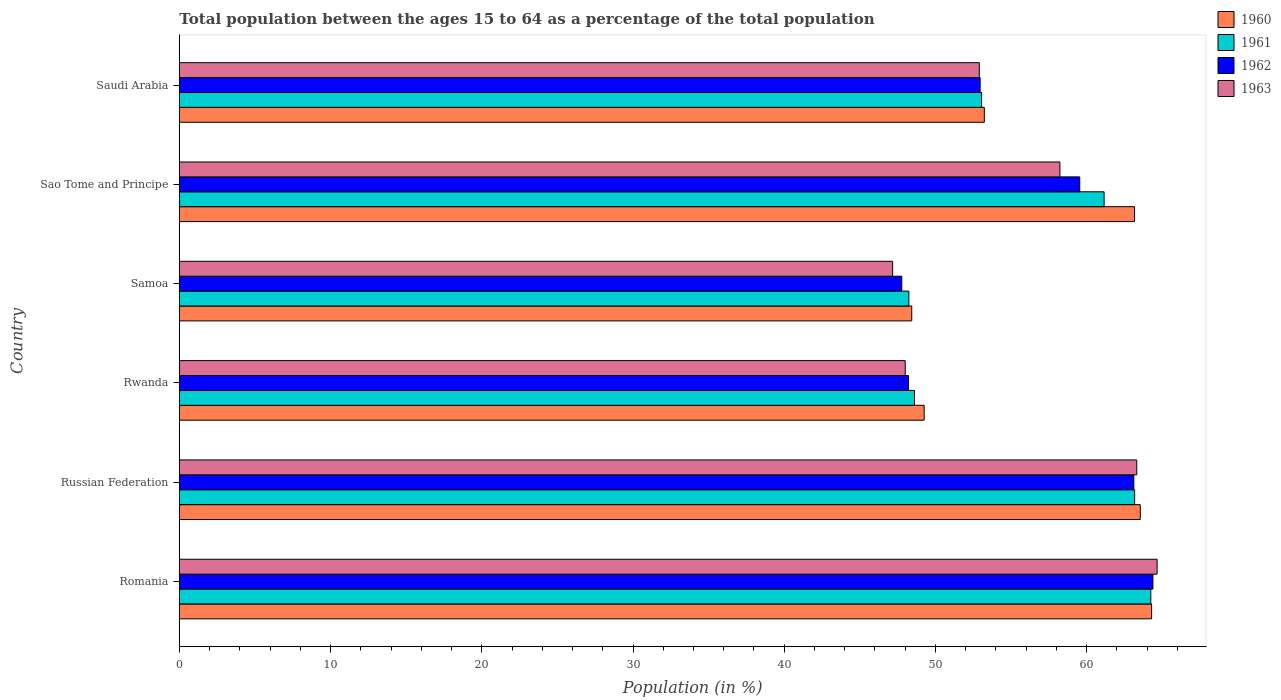How many different coloured bars are there?
Provide a short and direct response. 4. How many groups of bars are there?
Your answer should be very brief. 6. Are the number of bars on each tick of the Y-axis equal?
Provide a short and direct response. Yes. What is the label of the 6th group of bars from the top?
Your answer should be very brief. Romania. In how many cases, is the number of bars for a given country not equal to the number of legend labels?
Ensure brevity in your answer.  0. What is the percentage of the population ages 15 to 64 in 1963 in Sao Tome and Principe?
Your response must be concise. 58.23. Across all countries, what is the maximum percentage of the population ages 15 to 64 in 1963?
Provide a short and direct response. 64.66. Across all countries, what is the minimum percentage of the population ages 15 to 64 in 1960?
Your answer should be very brief. 48.43. In which country was the percentage of the population ages 15 to 64 in 1961 maximum?
Give a very brief answer. Romania. In which country was the percentage of the population ages 15 to 64 in 1962 minimum?
Offer a very short reply. Samoa. What is the total percentage of the population ages 15 to 64 in 1963 in the graph?
Your answer should be compact. 334.28. What is the difference between the percentage of the population ages 15 to 64 in 1962 in Russian Federation and that in Rwanda?
Make the answer very short. 14.9. What is the difference between the percentage of the population ages 15 to 64 in 1960 in Russian Federation and the percentage of the population ages 15 to 64 in 1961 in Romania?
Your response must be concise. -0.7. What is the average percentage of the population ages 15 to 64 in 1960 per country?
Keep it short and to the point. 56.99. What is the difference between the percentage of the population ages 15 to 64 in 1962 and percentage of the population ages 15 to 64 in 1963 in Romania?
Your answer should be compact. -0.28. In how many countries, is the percentage of the population ages 15 to 64 in 1960 greater than 46 ?
Make the answer very short. 6. What is the ratio of the percentage of the population ages 15 to 64 in 1960 in Russian Federation to that in Sao Tome and Principe?
Make the answer very short. 1.01. Is the percentage of the population ages 15 to 64 in 1961 in Samoa less than that in Sao Tome and Principe?
Ensure brevity in your answer.  Yes. What is the difference between the highest and the second highest percentage of the population ages 15 to 64 in 1961?
Your response must be concise. 1.07. What is the difference between the highest and the lowest percentage of the population ages 15 to 64 in 1963?
Offer a terse response. 17.49. In how many countries, is the percentage of the population ages 15 to 64 in 1963 greater than the average percentage of the population ages 15 to 64 in 1963 taken over all countries?
Keep it short and to the point. 3. Is the sum of the percentage of the population ages 15 to 64 in 1961 in Romania and Samoa greater than the maximum percentage of the population ages 15 to 64 in 1960 across all countries?
Provide a succinct answer. Yes. Is it the case that in every country, the sum of the percentage of the population ages 15 to 64 in 1963 and percentage of the population ages 15 to 64 in 1962 is greater than the sum of percentage of the population ages 15 to 64 in 1960 and percentage of the population ages 15 to 64 in 1961?
Give a very brief answer. No. How many bars are there?
Your response must be concise. 24. Are all the bars in the graph horizontal?
Give a very brief answer. Yes. What is the title of the graph?
Your answer should be very brief. Total population between the ages 15 to 64 as a percentage of the total population. What is the label or title of the X-axis?
Make the answer very short. Population (in %). What is the Population (in %) of 1960 in Romania?
Make the answer very short. 64.3. What is the Population (in %) of 1961 in Romania?
Your answer should be very brief. 64.24. What is the Population (in %) of 1962 in Romania?
Your answer should be very brief. 64.38. What is the Population (in %) of 1963 in Romania?
Offer a very short reply. 64.66. What is the Population (in %) of 1960 in Russian Federation?
Give a very brief answer. 63.55. What is the Population (in %) of 1961 in Russian Federation?
Offer a very short reply. 63.18. What is the Population (in %) of 1962 in Russian Federation?
Your answer should be compact. 63.12. What is the Population (in %) in 1963 in Russian Federation?
Your answer should be compact. 63.31. What is the Population (in %) of 1960 in Rwanda?
Provide a short and direct response. 49.26. What is the Population (in %) in 1961 in Rwanda?
Give a very brief answer. 48.62. What is the Population (in %) of 1962 in Rwanda?
Provide a short and direct response. 48.22. What is the Population (in %) of 1963 in Rwanda?
Provide a succinct answer. 48. What is the Population (in %) of 1960 in Samoa?
Offer a very short reply. 48.43. What is the Population (in %) in 1961 in Samoa?
Offer a terse response. 48.24. What is the Population (in %) in 1962 in Samoa?
Your response must be concise. 47.77. What is the Population (in %) in 1963 in Samoa?
Provide a short and direct response. 47.17. What is the Population (in %) in 1960 in Sao Tome and Principe?
Provide a short and direct response. 63.17. What is the Population (in %) in 1961 in Sao Tome and Principe?
Offer a very short reply. 61.16. What is the Population (in %) in 1962 in Sao Tome and Principe?
Offer a very short reply. 59.54. What is the Population (in %) of 1963 in Sao Tome and Principe?
Make the answer very short. 58.23. What is the Population (in %) in 1960 in Saudi Arabia?
Provide a succinct answer. 53.23. What is the Population (in %) of 1961 in Saudi Arabia?
Keep it short and to the point. 53.05. What is the Population (in %) in 1962 in Saudi Arabia?
Keep it short and to the point. 52.96. What is the Population (in %) of 1963 in Saudi Arabia?
Keep it short and to the point. 52.9. Across all countries, what is the maximum Population (in %) in 1960?
Your answer should be compact. 64.3. Across all countries, what is the maximum Population (in %) in 1961?
Offer a terse response. 64.24. Across all countries, what is the maximum Population (in %) in 1962?
Offer a very short reply. 64.38. Across all countries, what is the maximum Population (in %) of 1963?
Provide a succinct answer. 64.66. Across all countries, what is the minimum Population (in %) in 1960?
Make the answer very short. 48.43. Across all countries, what is the minimum Population (in %) in 1961?
Your response must be concise. 48.24. Across all countries, what is the minimum Population (in %) of 1962?
Offer a very short reply. 47.77. Across all countries, what is the minimum Population (in %) of 1963?
Offer a terse response. 47.17. What is the total Population (in %) of 1960 in the graph?
Make the answer very short. 341.94. What is the total Population (in %) of 1961 in the graph?
Make the answer very short. 338.49. What is the total Population (in %) of 1962 in the graph?
Provide a short and direct response. 336. What is the total Population (in %) in 1963 in the graph?
Offer a terse response. 334.28. What is the difference between the Population (in %) of 1960 in Romania and that in Russian Federation?
Your answer should be very brief. 0.75. What is the difference between the Population (in %) in 1961 in Romania and that in Russian Federation?
Offer a very short reply. 1.07. What is the difference between the Population (in %) of 1962 in Romania and that in Russian Federation?
Offer a terse response. 1.26. What is the difference between the Population (in %) in 1963 in Romania and that in Russian Federation?
Ensure brevity in your answer.  1.35. What is the difference between the Population (in %) of 1960 in Romania and that in Rwanda?
Offer a very short reply. 15.04. What is the difference between the Population (in %) in 1961 in Romania and that in Rwanda?
Make the answer very short. 15.63. What is the difference between the Population (in %) of 1962 in Romania and that in Rwanda?
Make the answer very short. 16.17. What is the difference between the Population (in %) of 1963 in Romania and that in Rwanda?
Give a very brief answer. 16.66. What is the difference between the Population (in %) of 1960 in Romania and that in Samoa?
Give a very brief answer. 15.86. What is the difference between the Population (in %) of 1961 in Romania and that in Samoa?
Your response must be concise. 16. What is the difference between the Population (in %) of 1962 in Romania and that in Samoa?
Your answer should be very brief. 16.61. What is the difference between the Population (in %) of 1963 in Romania and that in Samoa?
Your answer should be compact. 17.49. What is the difference between the Population (in %) of 1960 in Romania and that in Sao Tome and Principe?
Make the answer very short. 1.13. What is the difference between the Population (in %) in 1961 in Romania and that in Sao Tome and Principe?
Give a very brief answer. 3.09. What is the difference between the Population (in %) of 1962 in Romania and that in Sao Tome and Principe?
Give a very brief answer. 4.84. What is the difference between the Population (in %) of 1963 in Romania and that in Sao Tome and Principe?
Your answer should be very brief. 6.43. What is the difference between the Population (in %) in 1960 in Romania and that in Saudi Arabia?
Offer a terse response. 11.06. What is the difference between the Population (in %) of 1961 in Romania and that in Saudi Arabia?
Your answer should be very brief. 11.19. What is the difference between the Population (in %) in 1962 in Romania and that in Saudi Arabia?
Provide a succinct answer. 11.43. What is the difference between the Population (in %) in 1963 in Romania and that in Saudi Arabia?
Your answer should be compact. 11.76. What is the difference between the Population (in %) in 1960 in Russian Federation and that in Rwanda?
Give a very brief answer. 14.29. What is the difference between the Population (in %) in 1961 in Russian Federation and that in Rwanda?
Your response must be concise. 14.56. What is the difference between the Population (in %) in 1962 in Russian Federation and that in Rwanda?
Offer a very short reply. 14.9. What is the difference between the Population (in %) in 1963 in Russian Federation and that in Rwanda?
Keep it short and to the point. 15.31. What is the difference between the Population (in %) of 1960 in Russian Federation and that in Samoa?
Your answer should be compact. 15.11. What is the difference between the Population (in %) in 1961 in Russian Federation and that in Samoa?
Your response must be concise. 14.93. What is the difference between the Population (in %) in 1962 in Russian Federation and that in Samoa?
Offer a terse response. 15.35. What is the difference between the Population (in %) in 1963 in Russian Federation and that in Samoa?
Make the answer very short. 16.15. What is the difference between the Population (in %) in 1960 in Russian Federation and that in Sao Tome and Principe?
Your answer should be compact. 0.38. What is the difference between the Population (in %) of 1961 in Russian Federation and that in Sao Tome and Principe?
Give a very brief answer. 2.02. What is the difference between the Population (in %) in 1962 in Russian Federation and that in Sao Tome and Principe?
Your answer should be compact. 3.58. What is the difference between the Population (in %) of 1963 in Russian Federation and that in Sao Tome and Principe?
Give a very brief answer. 5.08. What is the difference between the Population (in %) in 1960 in Russian Federation and that in Saudi Arabia?
Provide a succinct answer. 10.31. What is the difference between the Population (in %) of 1961 in Russian Federation and that in Saudi Arabia?
Offer a very short reply. 10.12. What is the difference between the Population (in %) of 1962 in Russian Federation and that in Saudi Arabia?
Your response must be concise. 10.16. What is the difference between the Population (in %) of 1963 in Russian Federation and that in Saudi Arabia?
Ensure brevity in your answer.  10.41. What is the difference between the Population (in %) in 1960 in Rwanda and that in Samoa?
Your response must be concise. 0.82. What is the difference between the Population (in %) of 1961 in Rwanda and that in Samoa?
Ensure brevity in your answer.  0.37. What is the difference between the Population (in %) in 1962 in Rwanda and that in Samoa?
Provide a short and direct response. 0.44. What is the difference between the Population (in %) of 1963 in Rwanda and that in Samoa?
Offer a terse response. 0.83. What is the difference between the Population (in %) in 1960 in Rwanda and that in Sao Tome and Principe?
Your answer should be compact. -13.91. What is the difference between the Population (in %) of 1961 in Rwanda and that in Sao Tome and Principe?
Offer a terse response. -12.54. What is the difference between the Population (in %) in 1962 in Rwanda and that in Sao Tome and Principe?
Provide a short and direct response. -11.33. What is the difference between the Population (in %) in 1963 in Rwanda and that in Sao Tome and Principe?
Keep it short and to the point. -10.23. What is the difference between the Population (in %) of 1960 in Rwanda and that in Saudi Arabia?
Ensure brevity in your answer.  -3.98. What is the difference between the Population (in %) in 1961 in Rwanda and that in Saudi Arabia?
Offer a terse response. -4.44. What is the difference between the Population (in %) in 1962 in Rwanda and that in Saudi Arabia?
Your response must be concise. -4.74. What is the difference between the Population (in %) in 1963 in Rwanda and that in Saudi Arabia?
Offer a very short reply. -4.9. What is the difference between the Population (in %) in 1960 in Samoa and that in Sao Tome and Principe?
Your answer should be compact. -14.73. What is the difference between the Population (in %) in 1961 in Samoa and that in Sao Tome and Principe?
Offer a terse response. -12.91. What is the difference between the Population (in %) of 1962 in Samoa and that in Sao Tome and Principe?
Keep it short and to the point. -11.77. What is the difference between the Population (in %) of 1963 in Samoa and that in Sao Tome and Principe?
Provide a succinct answer. -11.06. What is the difference between the Population (in %) in 1960 in Samoa and that in Saudi Arabia?
Your response must be concise. -4.8. What is the difference between the Population (in %) of 1961 in Samoa and that in Saudi Arabia?
Your response must be concise. -4.81. What is the difference between the Population (in %) of 1962 in Samoa and that in Saudi Arabia?
Offer a very short reply. -5.18. What is the difference between the Population (in %) in 1963 in Samoa and that in Saudi Arabia?
Keep it short and to the point. -5.73. What is the difference between the Population (in %) in 1960 in Sao Tome and Principe and that in Saudi Arabia?
Keep it short and to the point. 9.94. What is the difference between the Population (in %) in 1961 in Sao Tome and Principe and that in Saudi Arabia?
Provide a short and direct response. 8.1. What is the difference between the Population (in %) in 1962 in Sao Tome and Principe and that in Saudi Arabia?
Your answer should be compact. 6.59. What is the difference between the Population (in %) of 1963 in Sao Tome and Principe and that in Saudi Arabia?
Give a very brief answer. 5.33. What is the difference between the Population (in %) in 1960 in Romania and the Population (in %) in 1961 in Russian Federation?
Provide a short and direct response. 1.12. What is the difference between the Population (in %) of 1960 in Romania and the Population (in %) of 1962 in Russian Federation?
Your answer should be very brief. 1.18. What is the difference between the Population (in %) in 1960 in Romania and the Population (in %) in 1963 in Russian Federation?
Provide a short and direct response. 0.98. What is the difference between the Population (in %) in 1961 in Romania and the Population (in %) in 1962 in Russian Federation?
Ensure brevity in your answer.  1.12. What is the difference between the Population (in %) in 1961 in Romania and the Population (in %) in 1963 in Russian Federation?
Keep it short and to the point. 0.93. What is the difference between the Population (in %) of 1962 in Romania and the Population (in %) of 1963 in Russian Federation?
Provide a short and direct response. 1.07. What is the difference between the Population (in %) of 1960 in Romania and the Population (in %) of 1961 in Rwanda?
Make the answer very short. 15.68. What is the difference between the Population (in %) of 1960 in Romania and the Population (in %) of 1962 in Rwanda?
Make the answer very short. 16.08. What is the difference between the Population (in %) of 1960 in Romania and the Population (in %) of 1963 in Rwanda?
Provide a short and direct response. 16.29. What is the difference between the Population (in %) of 1961 in Romania and the Population (in %) of 1962 in Rwanda?
Keep it short and to the point. 16.03. What is the difference between the Population (in %) in 1961 in Romania and the Population (in %) in 1963 in Rwanda?
Give a very brief answer. 16.24. What is the difference between the Population (in %) of 1962 in Romania and the Population (in %) of 1963 in Rwanda?
Your answer should be compact. 16.38. What is the difference between the Population (in %) of 1960 in Romania and the Population (in %) of 1961 in Samoa?
Provide a short and direct response. 16.05. What is the difference between the Population (in %) in 1960 in Romania and the Population (in %) in 1962 in Samoa?
Provide a short and direct response. 16.52. What is the difference between the Population (in %) in 1960 in Romania and the Population (in %) in 1963 in Samoa?
Your response must be concise. 17.13. What is the difference between the Population (in %) in 1961 in Romania and the Population (in %) in 1962 in Samoa?
Your response must be concise. 16.47. What is the difference between the Population (in %) of 1961 in Romania and the Population (in %) of 1963 in Samoa?
Your response must be concise. 17.07. What is the difference between the Population (in %) in 1962 in Romania and the Population (in %) in 1963 in Samoa?
Keep it short and to the point. 17.21. What is the difference between the Population (in %) of 1960 in Romania and the Population (in %) of 1961 in Sao Tome and Principe?
Make the answer very short. 3.14. What is the difference between the Population (in %) in 1960 in Romania and the Population (in %) in 1962 in Sao Tome and Principe?
Your answer should be compact. 4.75. What is the difference between the Population (in %) of 1960 in Romania and the Population (in %) of 1963 in Sao Tome and Principe?
Provide a short and direct response. 6.06. What is the difference between the Population (in %) of 1961 in Romania and the Population (in %) of 1962 in Sao Tome and Principe?
Provide a succinct answer. 4.7. What is the difference between the Population (in %) of 1961 in Romania and the Population (in %) of 1963 in Sao Tome and Principe?
Offer a very short reply. 6.01. What is the difference between the Population (in %) in 1962 in Romania and the Population (in %) in 1963 in Sao Tome and Principe?
Provide a short and direct response. 6.15. What is the difference between the Population (in %) of 1960 in Romania and the Population (in %) of 1961 in Saudi Arabia?
Your answer should be compact. 11.24. What is the difference between the Population (in %) of 1960 in Romania and the Population (in %) of 1962 in Saudi Arabia?
Make the answer very short. 11.34. What is the difference between the Population (in %) in 1960 in Romania and the Population (in %) in 1963 in Saudi Arabia?
Ensure brevity in your answer.  11.4. What is the difference between the Population (in %) of 1961 in Romania and the Population (in %) of 1962 in Saudi Arabia?
Provide a succinct answer. 11.29. What is the difference between the Population (in %) in 1961 in Romania and the Population (in %) in 1963 in Saudi Arabia?
Make the answer very short. 11.34. What is the difference between the Population (in %) in 1962 in Romania and the Population (in %) in 1963 in Saudi Arabia?
Your response must be concise. 11.48. What is the difference between the Population (in %) of 1960 in Russian Federation and the Population (in %) of 1961 in Rwanda?
Give a very brief answer. 14.93. What is the difference between the Population (in %) of 1960 in Russian Federation and the Population (in %) of 1962 in Rwanda?
Keep it short and to the point. 15.33. What is the difference between the Population (in %) of 1960 in Russian Federation and the Population (in %) of 1963 in Rwanda?
Give a very brief answer. 15.55. What is the difference between the Population (in %) in 1961 in Russian Federation and the Population (in %) in 1962 in Rwanda?
Provide a succinct answer. 14.96. What is the difference between the Population (in %) of 1961 in Russian Federation and the Population (in %) of 1963 in Rwanda?
Offer a very short reply. 15.17. What is the difference between the Population (in %) of 1962 in Russian Federation and the Population (in %) of 1963 in Rwanda?
Ensure brevity in your answer.  15.12. What is the difference between the Population (in %) in 1960 in Russian Federation and the Population (in %) in 1961 in Samoa?
Provide a succinct answer. 15.31. What is the difference between the Population (in %) of 1960 in Russian Federation and the Population (in %) of 1962 in Samoa?
Ensure brevity in your answer.  15.78. What is the difference between the Population (in %) of 1960 in Russian Federation and the Population (in %) of 1963 in Samoa?
Keep it short and to the point. 16.38. What is the difference between the Population (in %) in 1961 in Russian Federation and the Population (in %) in 1962 in Samoa?
Make the answer very short. 15.4. What is the difference between the Population (in %) in 1961 in Russian Federation and the Population (in %) in 1963 in Samoa?
Make the answer very short. 16.01. What is the difference between the Population (in %) in 1962 in Russian Federation and the Population (in %) in 1963 in Samoa?
Your response must be concise. 15.95. What is the difference between the Population (in %) in 1960 in Russian Federation and the Population (in %) in 1961 in Sao Tome and Principe?
Give a very brief answer. 2.39. What is the difference between the Population (in %) in 1960 in Russian Federation and the Population (in %) in 1962 in Sao Tome and Principe?
Offer a terse response. 4. What is the difference between the Population (in %) in 1960 in Russian Federation and the Population (in %) in 1963 in Sao Tome and Principe?
Make the answer very short. 5.32. What is the difference between the Population (in %) in 1961 in Russian Federation and the Population (in %) in 1962 in Sao Tome and Principe?
Your answer should be compact. 3.63. What is the difference between the Population (in %) of 1961 in Russian Federation and the Population (in %) of 1963 in Sao Tome and Principe?
Your answer should be very brief. 4.94. What is the difference between the Population (in %) in 1962 in Russian Federation and the Population (in %) in 1963 in Sao Tome and Principe?
Provide a short and direct response. 4.89. What is the difference between the Population (in %) of 1960 in Russian Federation and the Population (in %) of 1961 in Saudi Arabia?
Make the answer very short. 10.49. What is the difference between the Population (in %) in 1960 in Russian Federation and the Population (in %) in 1962 in Saudi Arabia?
Your response must be concise. 10.59. What is the difference between the Population (in %) of 1960 in Russian Federation and the Population (in %) of 1963 in Saudi Arabia?
Ensure brevity in your answer.  10.65. What is the difference between the Population (in %) in 1961 in Russian Federation and the Population (in %) in 1962 in Saudi Arabia?
Your response must be concise. 10.22. What is the difference between the Population (in %) in 1961 in Russian Federation and the Population (in %) in 1963 in Saudi Arabia?
Provide a succinct answer. 10.27. What is the difference between the Population (in %) of 1962 in Russian Federation and the Population (in %) of 1963 in Saudi Arabia?
Make the answer very short. 10.22. What is the difference between the Population (in %) in 1960 in Rwanda and the Population (in %) in 1961 in Samoa?
Give a very brief answer. 1.01. What is the difference between the Population (in %) of 1960 in Rwanda and the Population (in %) of 1962 in Samoa?
Provide a short and direct response. 1.48. What is the difference between the Population (in %) of 1960 in Rwanda and the Population (in %) of 1963 in Samoa?
Provide a succinct answer. 2.09. What is the difference between the Population (in %) in 1961 in Rwanda and the Population (in %) in 1962 in Samoa?
Your answer should be very brief. 0.84. What is the difference between the Population (in %) in 1961 in Rwanda and the Population (in %) in 1963 in Samoa?
Your answer should be compact. 1.45. What is the difference between the Population (in %) in 1962 in Rwanda and the Population (in %) in 1963 in Samoa?
Provide a short and direct response. 1.05. What is the difference between the Population (in %) in 1960 in Rwanda and the Population (in %) in 1961 in Sao Tome and Principe?
Your response must be concise. -11.9. What is the difference between the Population (in %) in 1960 in Rwanda and the Population (in %) in 1962 in Sao Tome and Principe?
Offer a very short reply. -10.29. What is the difference between the Population (in %) in 1960 in Rwanda and the Population (in %) in 1963 in Sao Tome and Principe?
Ensure brevity in your answer.  -8.98. What is the difference between the Population (in %) in 1961 in Rwanda and the Population (in %) in 1962 in Sao Tome and Principe?
Make the answer very short. -10.93. What is the difference between the Population (in %) in 1961 in Rwanda and the Population (in %) in 1963 in Sao Tome and Principe?
Ensure brevity in your answer.  -9.62. What is the difference between the Population (in %) of 1962 in Rwanda and the Population (in %) of 1963 in Sao Tome and Principe?
Provide a succinct answer. -10.01. What is the difference between the Population (in %) in 1960 in Rwanda and the Population (in %) in 1961 in Saudi Arabia?
Offer a terse response. -3.8. What is the difference between the Population (in %) in 1960 in Rwanda and the Population (in %) in 1962 in Saudi Arabia?
Your answer should be very brief. -3.7. What is the difference between the Population (in %) in 1960 in Rwanda and the Population (in %) in 1963 in Saudi Arabia?
Your response must be concise. -3.65. What is the difference between the Population (in %) in 1961 in Rwanda and the Population (in %) in 1962 in Saudi Arabia?
Provide a short and direct response. -4.34. What is the difference between the Population (in %) in 1961 in Rwanda and the Population (in %) in 1963 in Saudi Arabia?
Provide a succinct answer. -4.28. What is the difference between the Population (in %) in 1962 in Rwanda and the Population (in %) in 1963 in Saudi Arabia?
Offer a very short reply. -4.68. What is the difference between the Population (in %) in 1960 in Samoa and the Population (in %) in 1961 in Sao Tome and Principe?
Your answer should be compact. -12.72. What is the difference between the Population (in %) of 1960 in Samoa and the Population (in %) of 1962 in Sao Tome and Principe?
Your response must be concise. -11.11. What is the difference between the Population (in %) in 1960 in Samoa and the Population (in %) in 1963 in Sao Tome and Principe?
Offer a very short reply. -9.8. What is the difference between the Population (in %) in 1961 in Samoa and the Population (in %) in 1962 in Sao Tome and Principe?
Ensure brevity in your answer.  -11.3. What is the difference between the Population (in %) in 1961 in Samoa and the Population (in %) in 1963 in Sao Tome and Principe?
Make the answer very short. -9.99. What is the difference between the Population (in %) of 1962 in Samoa and the Population (in %) of 1963 in Sao Tome and Principe?
Give a very brief answer. -10.46. What is the difference between the Population (in %) in 1960 in Samoa and the Population (in %) in 1961 in Saudi Arabia?
Make the answer very short. -4.62. What is the difference between the Population (in %) of 1960 in Samoa and the Population (in %) of 1962 in Saudi Arabia?
Your answer should be very brief. -4.52. What is the difference between the Population (in %) of 1960 in Samoa and the Population (in %) of 1963 in Saudi Arabia?
Ensure brevity in your answer.  -4.47. What is the difference between the Population (in %) of 1961 in Samoa and the Population (in %) of 1962 in Saudi Arabia?
Provide a short and direct response. -4.71. What is the difference between the Population (in %) of 1961 in Samoa and the Population (in %) of 1963 in Saudi Arabia?
Make the answer very short. -4.66. What is the difference between the Population (in %) in 1962 in Samoa and the Population (in %) in 1963 in Saudi Arabia?
Ensure brevity in your answer.  -5.13. What is the difference between the Population (in %) in 1960 in Sao Tome and Principe and the Population (in %) in 1961 in Saudi Arabia?
Your answer should be compact. 10.11. What is the difference between the Population (in %) in 1960 in Sao Tome and Principe and the Population (in %) in 1962 in Saudi Arabia?
Offer a terse response. 10.21. What is the difference between the Population (in %) of 1960 in Sao Tome and Principe and the Population (in %) of 1963 in Saudi Arabia?
Keep it short and to the point. 10.27. What is the difference between the Population (in %) of 1961 in Sao Tome and Principe and the Population (in %) of 1962 in Saudi Arabia?
Ensure brevity in your answer.  8.2. What is the difference between the Population (in %) in 1961 in Sao Tome and Principe and the Population (in %) in 1963 in Saudi Arabia?
Your answer should be very brief. 8.25. What is the difference between the Population (in %) in 1962 in Sao Tome and Principe and the Population (in %) in 1963 in Saudi Arabia?
Make the answer very short. 6.64. What is the average Population (in %) in 1960 per country?
Offer a terse response. 56.99. What is the average Population (in %) in 1961 per country?
Ensure brevity in your answer.  56.41. What is the average Population (in %) in 1962 per country?
Ensure brevity in your answer.  56. What is the average Population (in %) in 1963 per country?
Ensure brevity in your answer.  55.71. What is the difference between the Population (in %) of 1960 and Population (in %) of 1961 in Romania?
Provide a short and direct response. 0.05. What is the difference between the Population (in %) in 1960 and Population (in %) in 1962 in Romania?
Ensure brevity in your answer.  -0.09. What is the difference between the Population (in %) in 1960 and Population (in %) in 1963 in Romania?
Your answer should be compact. -0.36. What is the difference between the Population (in %) in 1961 and Population (in %) in 1962 in Romania?
Offer a very short reply. -0.14. What is the difference between the Population (in %) in 1961 and Population (in %) in 1963 in Romania?
Your answer should be very brief. -0.42. What is the difference between the Population (in %) of 1962 and Population (in %) of 1963 in Romania?
Make the answer very short. -0.28. What is the difference between the Population (in %) of 1960 and Population (in %) of 1961 in Russian Federation?
Your response must be concise. 0.37. What is the difference between the Population (in %) of 1960 and Population (in %) of 1962 in Russian Federation?
Provide a short and direct response. 0.43. What is the difference between the Population (in %) in 1960 and Population (in %) in 1963 in Russian Federation?
Ensure brevity in your answer.  0.23. What is the difference between the Population (in %) of 1961 and Population (in %) of 1962 in Russian Federation?
Offer a very short reply. 0.06. What is the difference between the Population (in %) in 1961 and Population (in %) in 1963 in Russian Federation?
Your answer should be compact. -0.14. What is the difference between the Population (in %) of 1962 and Population (in %) of 1963 in Russian Federation?
Provide a short and direct response. -0.19. What is the difference between the Population (in %) of 1960 and Population (in %) of 1961 in Rwanda?
Your response must be concise. 0.64. What is the difference between the Population (in %) in 1960 and Population (in %) in 1962 in Rwanda?
Offer a terse response. 1.04. What is the difference between the Population (in %) in 1960 and Population (in %) in 1963 in Rwanda?
Your response must be concise. 1.25. What is the difference between the Population (in %) of 1961 and Population (in %) of 1962 in Rwanda?
Offer a terse response. 0.4. What is the difference between the Population (in %) of 1961 and Population (in %) of 1963 in Rwanda?
Provide a succinct answer. 0.61. What is the difference between the Population (in %) in 1962 and Population (in %) in 1963 in Rwanda?
Ensure brevity in your answer.  0.21. What is the difference between the Population (in %) in 1960 and Population (in %) in 1961 in Samoa?
Keep it short and to the point. 0.19. What is the difference between the Population (in %) in 1960 and Population (in %) in 1962 in Samoa?
Keep it short and to the point. 0.66. What is the difference between the Population (in %) of 1960 and Population (in %) of 1963 in Samoa?
Make the answer very short. 1.26. What is the difference between the Population (in %) of 1961 and Population (in %) of 1962 in Samoa?
Offer a terse response. 0.47. What is the difference between the Population (in %) of 1961 and Population (in %) of 1963 in Samoa?
Make the answer very short. 1.07. What is the difference between the Population (in %) of 1962 and Population (in %) of 1963 in Samoa?
Provide a succinct answer. 0.6. What is the difference between the Population (in %) in 1960 and Population (in %) in 1961 in Sao Tome and Principe?
Provide a short and direct response. 2.01. What is the difference between the Population (in %) in 1960 and Population (in %) in 1962 in Sao Tome and Principe?
Your response must be concise. 3.62. What is the difference between the Population (in %) in 1960 and Population (in %) in 1963 in Sao Tome and Principe?
Your answer should be compact. 4.94. What is the difference between the Population (in %) in 1961 and Population (in %) in 1962 in Sao Tome and Principe?
Your response must be concise. 1.61. What is the difference between the Population (in %) in 1961 and Population (in %) in 1963 in Sao Tome and Principe?
Give a very brief answer. 2.92. What is the difference between the Population (in %) of 1962 and Population (in %) of 1963 in Sao Tome and Principe?
Give a very brief answer. 1.31. What is the difference between the Population (in %) of 1960 and Population (in %) of 1961 in Saudi Arabia?
Give a very brief answer. 0.18. What is the difference between the Population (in %) of 1960 and Population (in %) of 1962 in Saudi Arabia?
Give a very brief answer. 0.28. What is the difference between the Population (in %) in 1960 and Population (in %) in 1963 in Saudi Arabia?
Offer a very short reply. 0.33. What is the difference between the Population (in %) in 1961 and Population (in %) in 1962 in Saudi Arabia?
Your answer should be compact. 0.1. What is the difference between the Population (in %) of 1961 and Population (in %) of 1963 in Saudi Arabia?
Give a very brief answer. 0.15. What is the difference between the Population (in %) in 1962 and Population (in %) in 1963 in Saudi Arabia?
Provide a succinct answer. 0.06. What is the ratio of the Population (in %) in 1960 in Romania to that in Russian Federation?
Your response must be concise. 1.01. What is the ratio of the Population (in %) in 1961 in Romania to that in Russian Federation?
Provide a succinct answer. 1.02. What is the ratio of the Population (in %) in 1962 in Romania to that in Russian Federation?
Offer a very short reply. 1.02. What is the ratio of the Population (in %) in 1963 in Romania to that in Russian Federation?
Make the answer very short. 1.02. What is the ratio of the Population (in %) of 1960 in Romania to that in Rwanda?
Provide a short and direct response. 1.31. What is the ratio of the Population (in %) of 1961 in Romania to that in Rwanda?
Give a very brief answer. 1.32. What is the ratio of the Population (in %) of 1962 in Romania to that in Rwanda?
Give a very brief answer. 1.34. What is the ratio of the Population (in %) in 1963 in Romania to that in Rwanda?
Your answer should be compact. 1.35. What is the ratio of the Population (in %) of 1960 in Romania to that in Samoa?
Keep it short and to the point. 1.33. What is the ratio of the Population (in %) of 1961 in Romania to that in Samoa?
Keep it short and to the point. 1.33. What is the ratio of the Population (in %) in 1962 in Romania to that in Samoa?
Offer a very short reply. 1.35. What is the ratio of the Population (in %) in 1963 in Romania to that in Samoa?
Keep it short and to the point. 1.37. What is the ratio of the Population (in %) in 1960 in Romania to that in Sao Tome and Principe?
Offer a terse response. 1.02. What is the ratio of the Population (in %) of 1961 in Romania to that in Sao Tome and Principe?
Offer a very short reply. 1.05. What is the ratio of the Population (in %) in 1962 in Romania to that in Sao Tome and Principe?
Offer a very short reply. 1.08. What is the ratio of the Population (in %) of 1963 in Romania to that in Sao Tome and Principe?
Keep it short and to the point. 1.11. What is the ratio of the Population (in %) of 1960 in Romania to that in Saudi Arabia?
Offer a very short reply. 1.21. What is the ratio of the Population (in %) of 1961 in Romania to that in Saudi Arabia?
Offer a terse response. 1.21. What is the ratio of the Population (in %) of 1962 in Romania to that in Saudi Arabia?
Provide a short and direct response. 1.22. What is the ratio of the Population (in %) of 1963 in Romania to that in Saudi Arabia?
Make the answer very short. 1.22. What is the ratio of the Population (in %) in 1960 in Russian Federation to that in Rwanda?
Ensure brevity in your answer.  1.29. What is the ratio of the Population (in %) of 1961 in Russian Federation to that in Rwanda?
Offer a very short reply. 1.3. What is the ratio of the Population (in %) of 1962 in Russian Federation to that in Rwanda?
Provide a succinct answer. 1.31. What is the ratio of the Population (in %) of 1963 in Russian Federation to that in Rwanda?
Provide a short and direct response. 1.32. What is the ratio of the Population (in %) in 1960 in Russian Federation to that in Samoa?
Your response must be concise. 1.31. What is the ratio of the Population (in %) of 1961 in Russian Federation to that in Samoa?
Your answer should be very brief. 1.31. What is the ratio of the Population (in %) of 1962 in Russian Federation to that in Samoa?
Give a very brief answer. 1.32. What is the ratio of the Population (in %) of 1963 in Russian Federation to that in Samoa?
Provide a succinct answer. 1.34. What is the ratio of the Population (in %) in 1961 in Russian Federation to that in Sao Tome and Principe?
Give a very brief answer. 1.03. What is the ratio of the Population (in %) of 1962 in Russian Federation to that in Sao Tome and Principe?
Keep it short and to the point. 1.06. What is the ratio of the Population (in %) in 1963 in Russian Federation to that in Sao Tome and Principe?
Keep it short and to the point. 1.09. What is the ratio of the Population (in %) of 1960 in Russian Federation to that in Saudi Arabia?
Keep it short and to the point. 1.19. What is the ratio of the Population (in %) of 1961 in Russian Federation to that in Saudi Arabia?
Provide a short and direct response. 1.19. What is the ratio of the Population (in %) in 1962 in Russian Federation to that in Saudi Arabia?
Your answer should be compact. 1.19. What is the ratio of the Population (in %) in 1963 in Russian Federation to that in Saudi Arabia?
Give a very brief answer. 1.2. What is the ratio of the Population (in %) of 1960 in Rwanda to that in Samoa?
Offer a very short reply. 1.02. What is the ratio of the Population (in %) of 1961 in Rwanda to that in Samoa?
Ensure brevity in your answer.  1.01. What is the ratio of the Population (in %) in 1962 in Rwanda to that in Samoa?
Provide a short and direct response. 1.01. What is the ratio of the Population (in %) in 1963 in Rwanda to that in Samoa?
Provide a short and direct response. 1.02. What is the ratio of the Population (in %) in 1960 in Rwanda to that in Sao Tome and Principe?
Offer a very short reply. 0.78. What is the ratio of the Population (in %) in 1961 in Rwanda to that in Sao Tome and Principe?
Make the answer very short. 0.8. What is the ratio of the Population (in %) of 1962 in Rwanda to that in Sao Tome and Principe?
Give a very brief answer. 0.81. What is the ratio of the Population (in %) of 1963 in Rwanda to that in Sao Tome and Principe?
Offer a very short reply. 0.82. What is the ratio of the Population (in %) of 1960 in Rwanda to that in Saudi Arabia?
Give a very brief answer. 0.93. What is the ratio of the Population (in %) of 1961 in Rwanda to that in Saudi Arabia?
Your answer should be compact. 0.92. What is the ratio of the Population (in %) in 1962 in Rwanda to that in Saudi Arabia?
Ensure brevity in your answer.  0.91. What is the ratio of the Population (in %) of 1963 in Rwanda to that in Saudi Arabia?
Your response must be concise. 0.91. What is the ratio of the Population (in %) of 1960 in Samoa to that in Sao Tome and Principe?
Provide a succinct answer. 0.77. What is the ratio of the Population (in %) in 1961 in Samoa to that in Sao Tome and Principe?
Provide a succinct answer. 0.79. What is the ratio of the Population (in %) in 1962 in Samoa to that in Sao Tome and Principe?
Your answer should be compact. 0.8. What is the ratio of the Population (in %) of 1963 in Samoa to that in Sao Tome and Principe?
Offer a terse response. 0.81. What is the ratio of the Population (in %) in 1960 in Samoa to that in Saudi Arabia?
Your answer should be compact. 0.91. What is the ratio of the Population (in %) of 1961 in Samoa to that in Saudi Arabia?
Ensure brevity in your answer.  0.91. What is the ratio of the Population (in %) in 1962 in Samoa to that in Saudi Arabia?
Your answer should be very brief. 0.9. What is the ratio of the Population (in %) of 1963 in Samoa to that in Saudi Arabia?
Provide a short and direct response. 0.89. What is the ratio of the Population (in %) in 1960 in Sao Tome and Principe to that in Saudi Arabia?
Your answer should be compact. 1.19. What is the ratio of the Population (in %) in 1961 in Sao Tome and Principe to that in Saudi Arabia?
Provide a short and direct response. 1.15. What is the ratio of the Population (in %) in 1962 in Sao Tome and Principe to that in Saudi Arabia?
Keep it short and to the point. 1.12. What is the ratio of the Population (in %) in 1963 in Sao Tome and Principe to that in Saudi Arabia?
Your answer should be very brief. 1.1. What is the difference between the highest and the second highest Population (in %) of 1960?
Provide a succinct answer. 0.75. What is the difference between the highest and the second highest Population (in %) in 1961?
Offer a terse response. 1.07. What is the difference between the highest and the second highest Population (in %) of 1962?
Offer a terse response. 1.26. What is the difference between the highest and the second highest Population (in %) in 1963?
Offer a very short reply. 1.35. What is the difference between the highest and the lowest Population (in %) of 1960?
Ensure brevity in your answer.  15.86. What is the difference between the highest and the lowest Population (in %) in 1961?
Make the answer very short. 16. What is the difference between the highest and the lowest Population (in %) in 1962?
Provide a succinct answer. 16.61. What is the difference between the highest and the lowest Population (in %) in 1963?
Your answer should be compact. 17.49. 